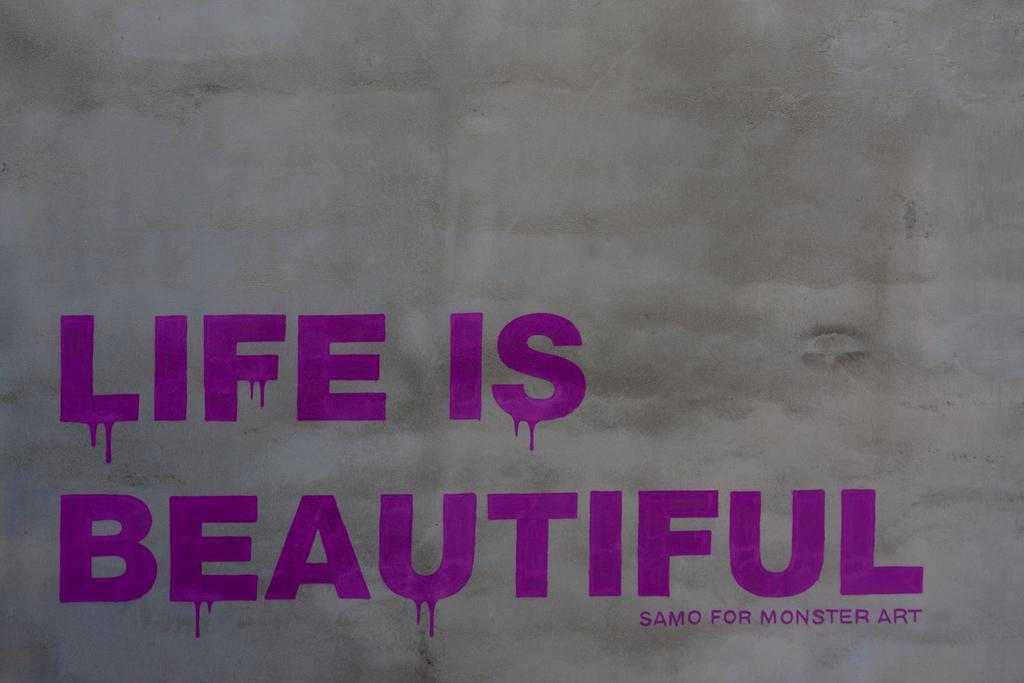<image>
Give a short and clear explanation of the subsequent image. Purple text of Life is beautiful along with Samo for Monster Art 